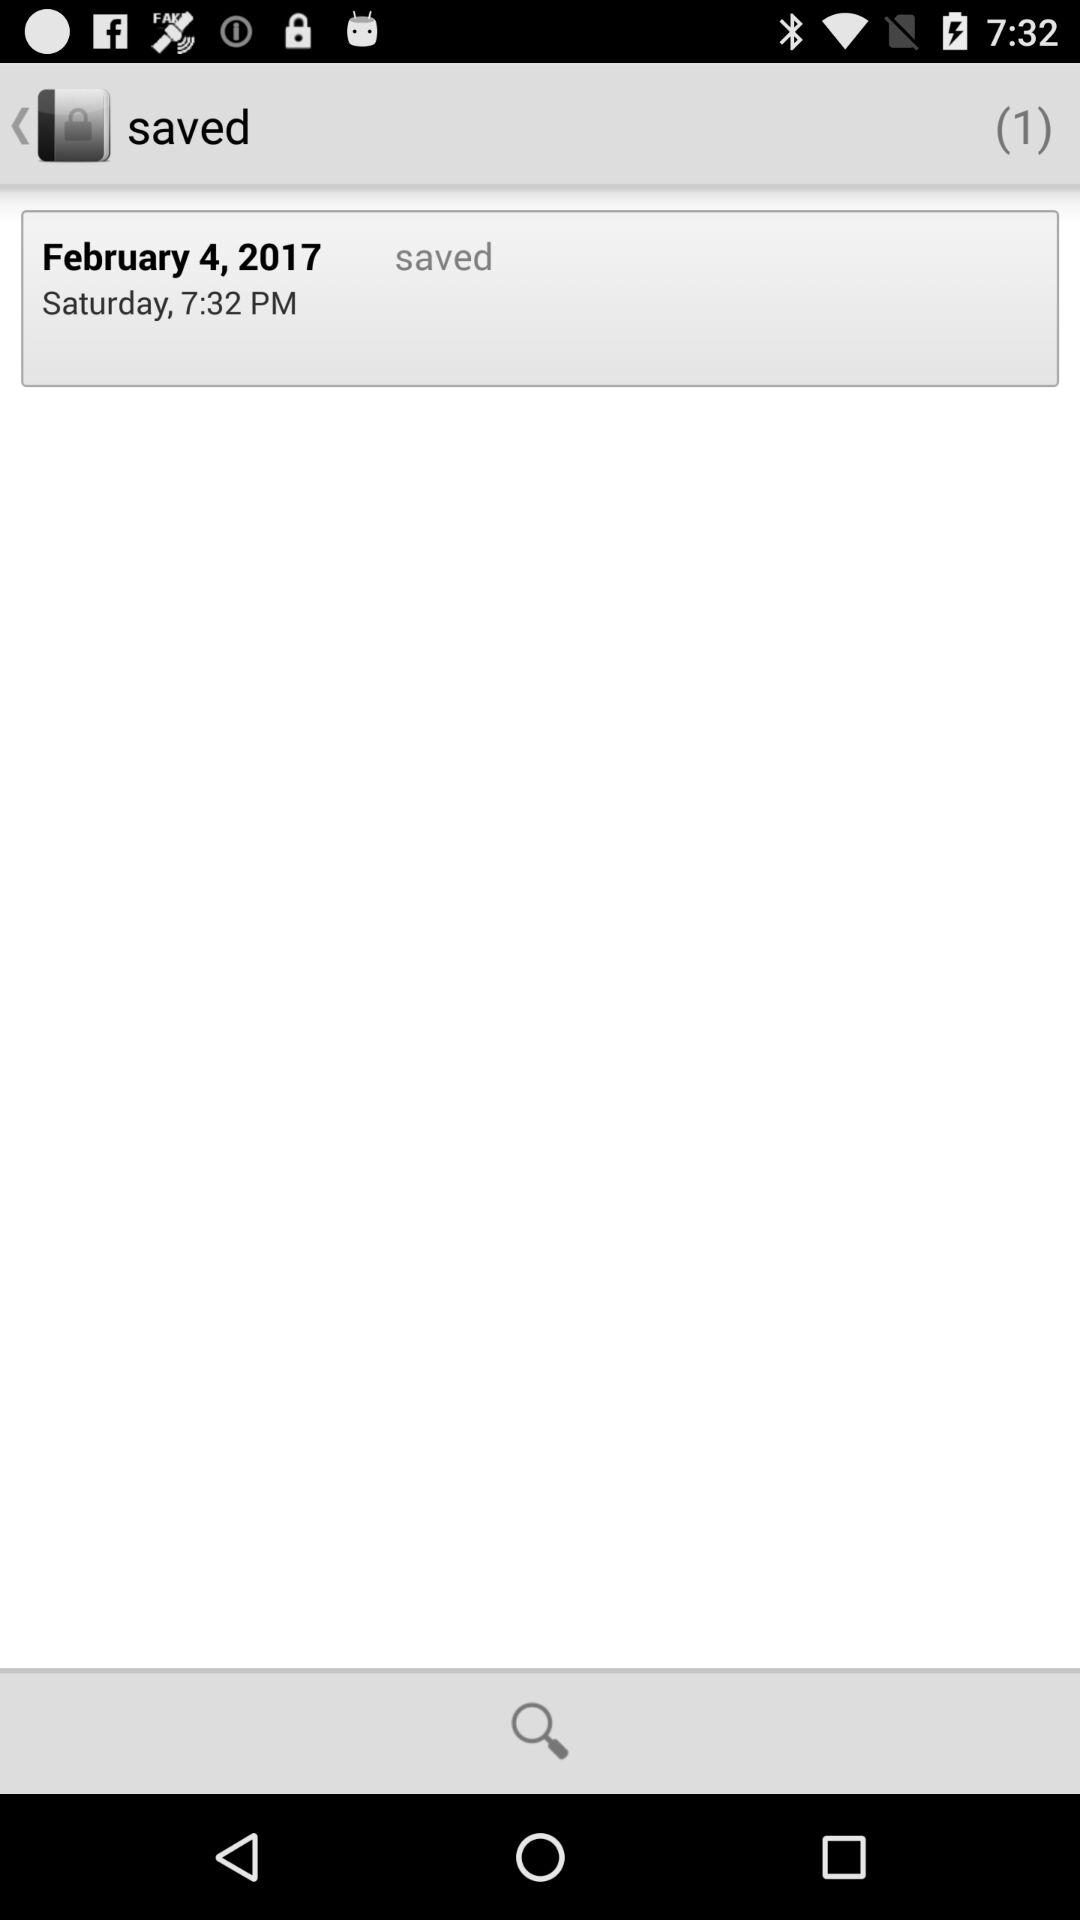On what date was the item saved? The item was saved on February 4, 2017. 